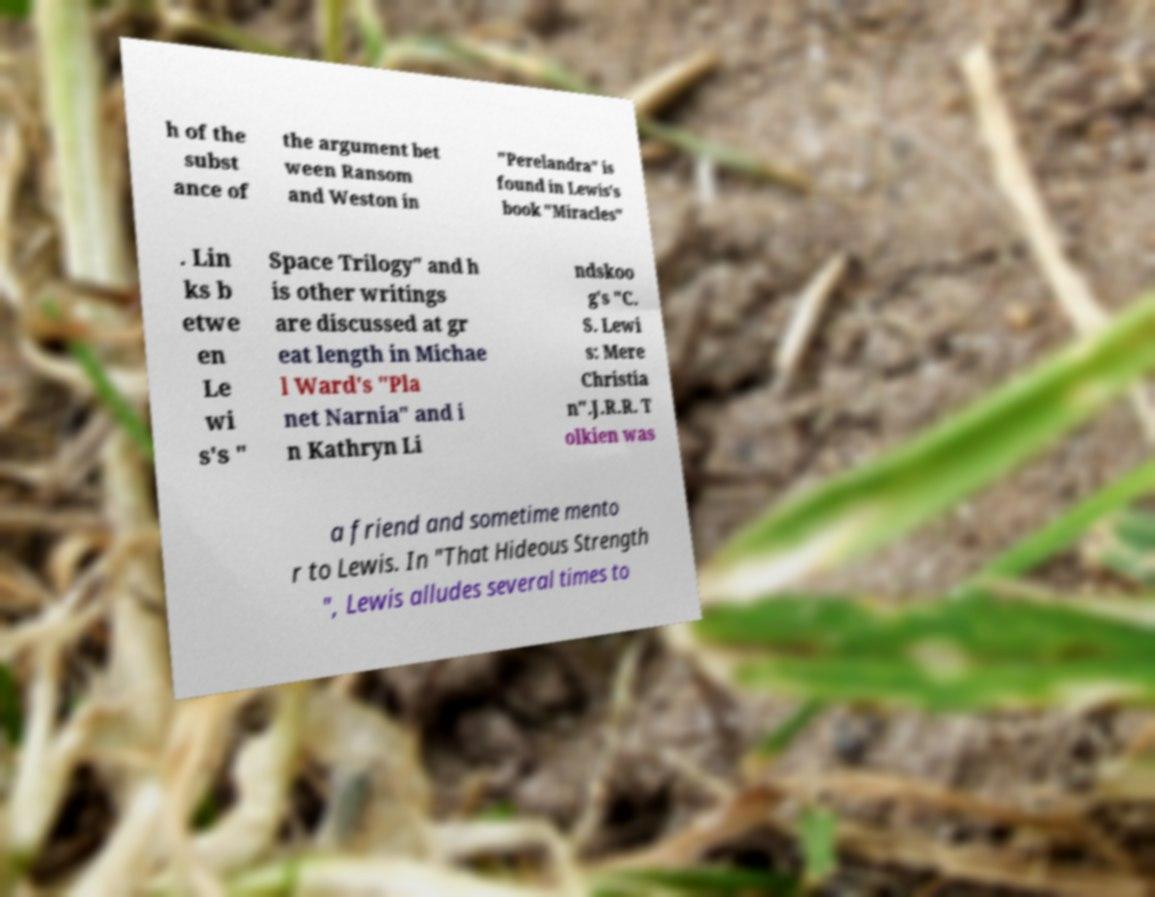There's text embedded in this image that I need extracted. Can you transcribe it verbatim? h of the subst ance of the argument bet ween Ransom and Weston in "Perelandra" is found in Lewis's book "Miracles" . Lin ks b etwe en Le wi s's " Space Trilogy" and h is other writings are discussed at gr eat length in Michae l Ward's "Pla net Narnia" and i n Kathryn Li ndskoo g's "C. S. Lewi s: Mere Christia n".J.R.R. T olkien was a friend and sometime mento r to Lewis. In "That Hideous Strength ", Lewis alludes several times to 